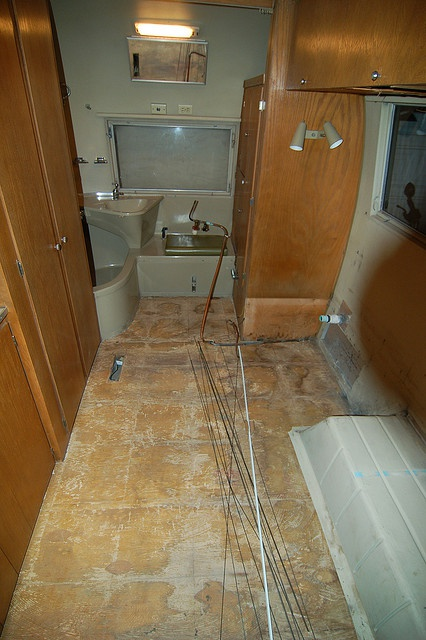Describe the objects in this image and their specific colors. I can see tv in black, gray, and darkgray tones, toilet in black, gray, and darkgreen tones, and sink in black, gray, and darkgray tones in this image. 